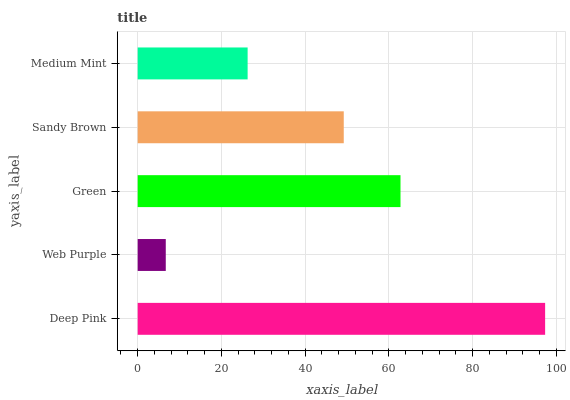Is Web Purple the minimum?
Answer yes or no. Yes. Is Deep Pink the maximum?
Answer yes or no. Yes. Is Green the minimum?
Answer yes or no. No. Is Green the maximum?
Answer yes or no. No. Is Green greater than Web Purple?
Answer yes or no. Yes. Is Web Purple less than Green?
Answer yes or no. Yes. Is Web Purple greater than Green?
Answer yes or no. No. Is Green less than Web Purple?
Answer yes or no. No. Is Sandy Brown the high median?
Answer yes or no. Yes. Is Sandy Brown the low median?
Answer yes or no. Yes. Is Green the high median?
Answer yes or no. No. Is Green the low median?
Answer yes or no. No. 